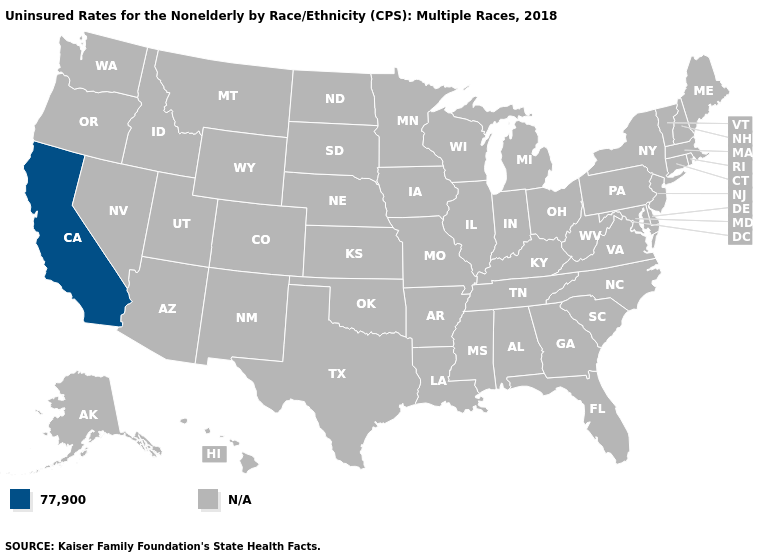Does the map have missing data?
Give a very brief answer. Yes. Name the states that have a value in the range 77,900?
Give a very brief answer. California. What is the value of Connecticut?
Answer briefly. N/A. What is the value of Ohio?
Quick response, please. N/A. How many symbols are there in the legend?
Concise answer only. 2. Does the first symbol in the legend represent the smallest category?
Concise answer only. Yes. Name the states that have a value in the range 77,900?
Quick response, please. California. What is the highest value in the USA?
Concise answer only. 77,900. Name the states that have a value in the range 77,900?
Short answer required. California. How many symbols are there in the legend?
Answer briefly. 2. 